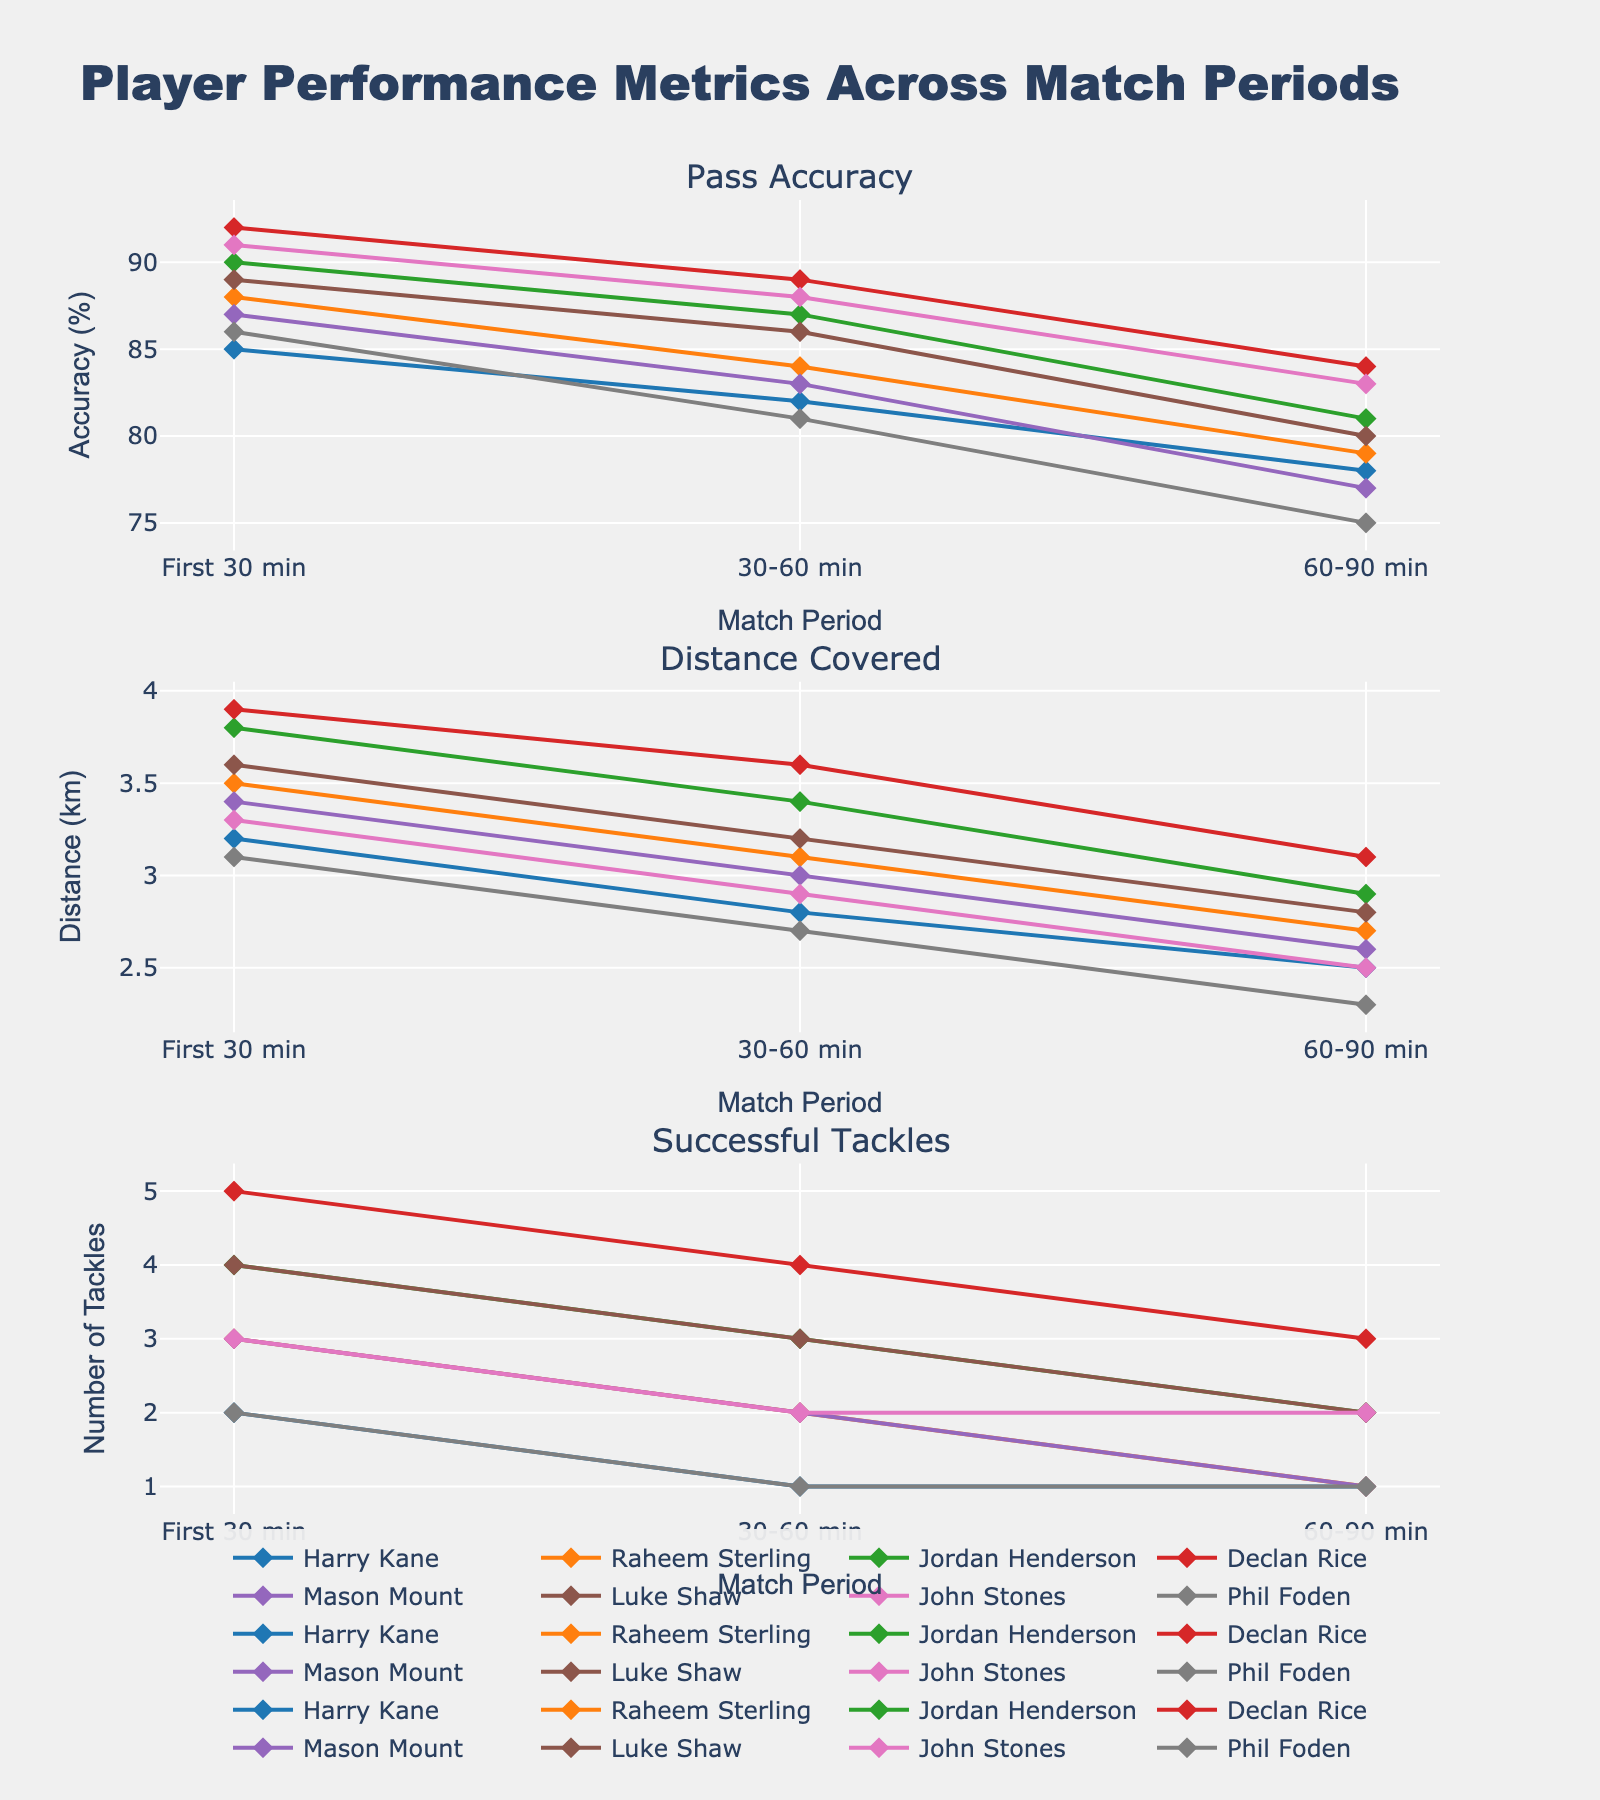what are the three metrics shown in the figure? The figure includes three subplots, each with a title indicating the metric it represents. The subplot titles are "Pass Accuracy," "Distance Covered," and "Successful Tackles."
Answer: Pass Accuracy, Distance Covered, Successful Tackles which player shows the highest pass accuracy in the first 30 minutes? The first subplot titled "Pass Accuracy" shows the pass accuracy for each player. Declan Rice's line reaches the highest value in the first 30 minutes, marked at 92.
Answer: Declan Rice how does Mason Mount's successful tackles change over the match periods? The third subplot titled "Successful Tackles" displays lines for each player's tackling performance. Mason Mount starts with 3 successful tackles in the first 30 minutes, decreases to 2 in the 30-60 minute period, and further decreases to 1 by the 60-90 minute period.
Answer: 3 to 2 to 1 which player shows the steepest decline in distance covered from the first 30 minutes to the last 30 minutes? The second subplot titled "Distance Covered" shows the distance covered over match periods for each player. Phil Foden shows the steepest decline, starting from 3.1 km in the first 30 minutes to 2.3 km in the last 30 minutes.
Answer: Phil Foden what is the overall trend observed for pass accuracy across players as the match progresses? In the first subplot "Pass Accuracy," the lines generally tend to slope downward, indicating that pass accuracy tends to decline for all players as the match progresses from the first 30 minutes to the last 30 minutes.
Answer: Decline how does Jordan Henderson's performance in successful tackles compare to Harry Kane's in the 30-60 minute period? In the third subplot "Successful Tackles," observing the 30-60 minute period, Jordan Henderson has 3 successful tackles while Harry Kane has 1 successful tackle, indicating Henderson achieved more tackles.
Answer: Jordan Henderson has more compare the performance of John Stones and Luke Shaw in terms of distance covered during the first 30 minutes. Looking at the second subplot "Distance Covered," John Stones covers 3.3 km and Luke Shaw covers 3.6 km in the first 30 minutes. Luke Shaw covers a greater distance than John Stones during this period.
Answer: Luke Shaw covers more distance which player maintains relatively consistent successful tackles across all match periods? In the third subplot "Successful Tackles," Declan Rice's line shows a relatively smaller decline from 5 to 4 to 3 compared to other players, indicating a more consistent tackling performance throughout the match.
Answer: Declan Rice what can you infer about Phil Foden's energy levels towards the end of the match based on two metrics? Phil Foden shows a decrease in both pass accuracy (86 to 81 to 75) and distance covered (3.1 km to 2.7 km to 2.3 km) across the match periods, suggesting a significant decline in his energy levels as the match progresses.
Answer: significant decline which player shows the least variation in pass accuracy over the match periods? In the first subplot "Pass Accuracy," compare the range of pass accuracies across players over time. John Stones shows relatively smaller changes (91 to 88 to 83) suggesting the least variation.
Answer: John Stones 